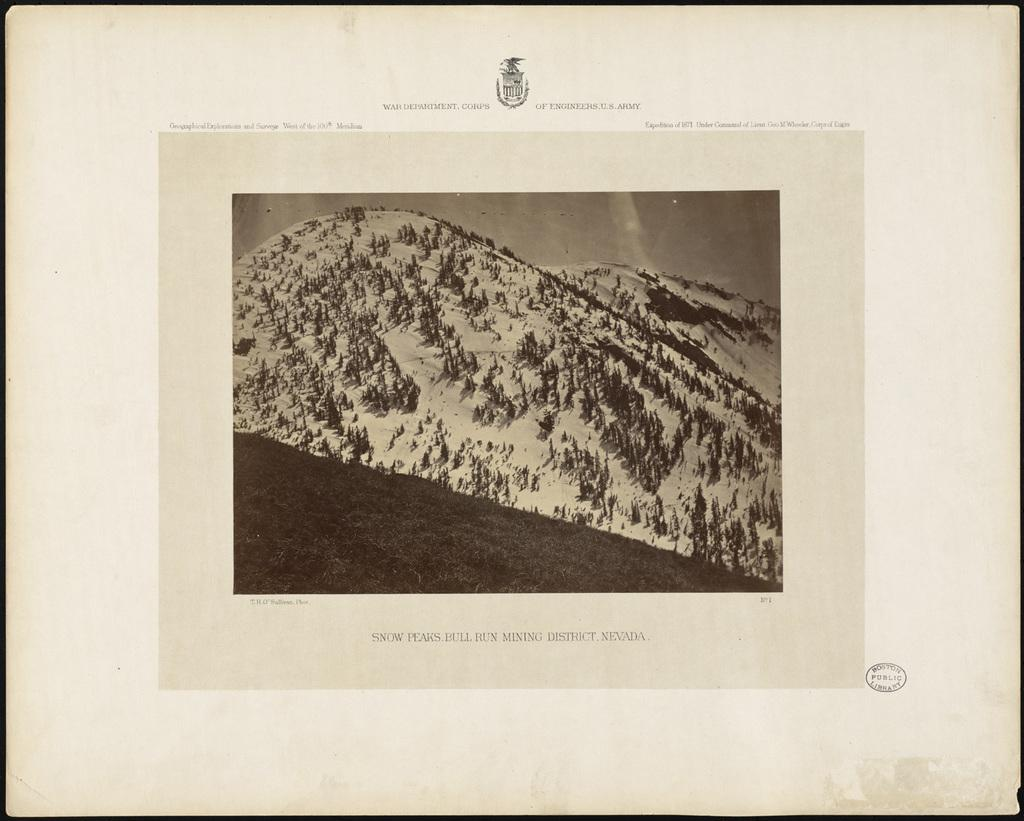What is the main subject of the poster in the image? The poster contains images of trees, mountains, and the sky. What else can be seen on the poster besides the images? There is text on the poster. What type of disease is depicted in the image? There is no disease depicted in the image; the poster contains images of trees, mountains, and the sky. How does the person in the image express regret? There is no person present in the image, and therefore no expression of regret can be observed. 